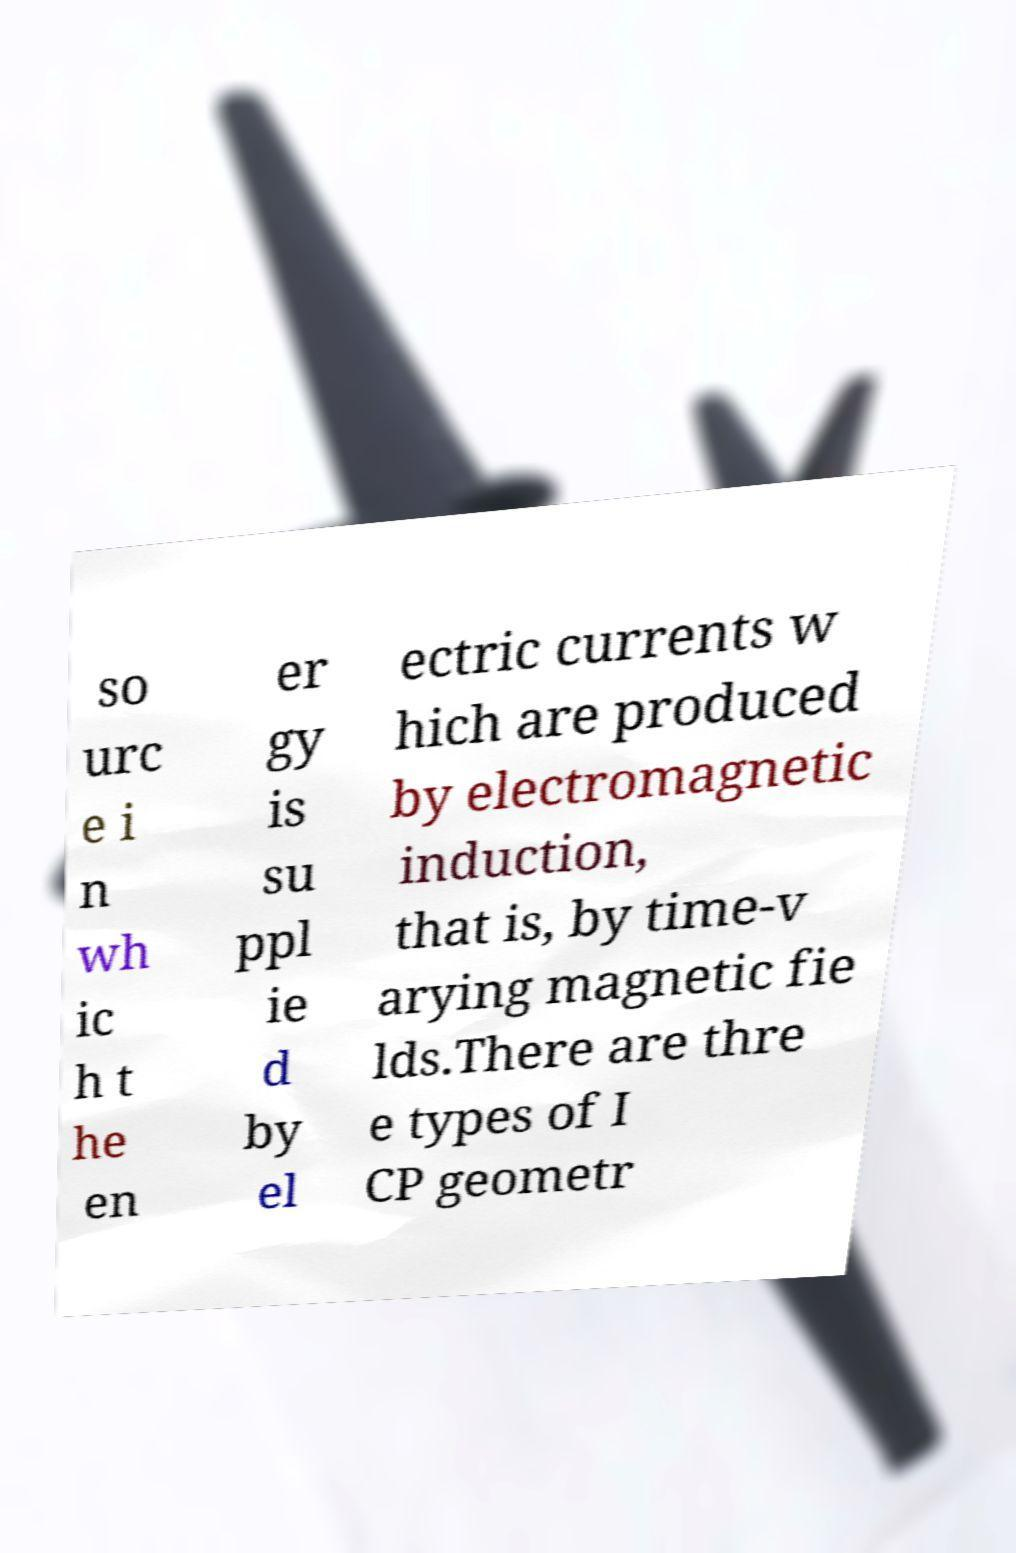Please identify and transcribe the text found in this image. so urc e i n wh ic h t he en er gy is su ppl ie d by el ectric currents w hich are produced by electromagnetic induction, that is, by time-v arying magnetic fie lds.There are thre e types of I CP geometr 